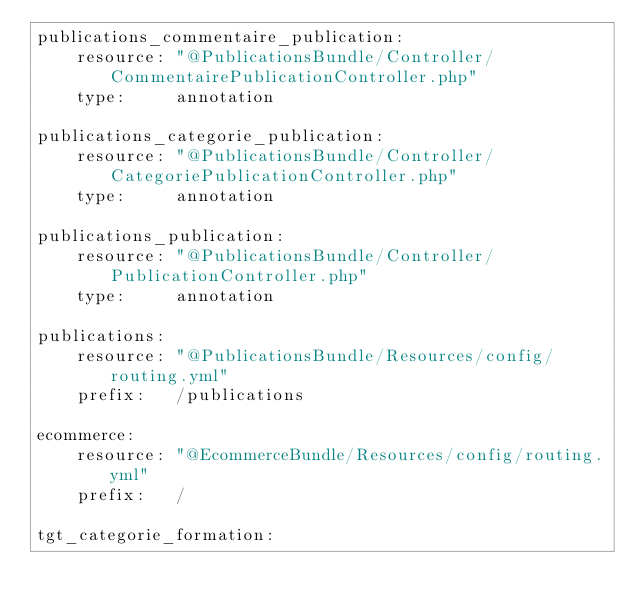<code> <loc_0><loc_0><loc_500><loc_500><_YAML_>publications_commentaire_publication:
    resource: "@PublicationsBundle/Controller/CommentairePublicationController.php"
    type:     annotation

publications_categorie_publication:
    resource: "@PublicationsBundle/Controller/CategoriePublicationController.php"
    type:     annotation

publications_publication:
    resource: "@PublicationsBundle/Controller/PublicationController.php"
    type:     annotation

publications:
    resource: "@PublicationsBundle/Resources/config/routing.yml"
    prefix:   /publications

ecommerce:
    resource: "@EcommerceBundle/Resources/config/routing.yml"
    prefix:   /

tgt_categorie_formation:</code> 